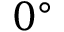Convert formula to latex. <formula><loc_0><loc_0><loc_500><loc_500>0 ^ { \circ }</formula> 